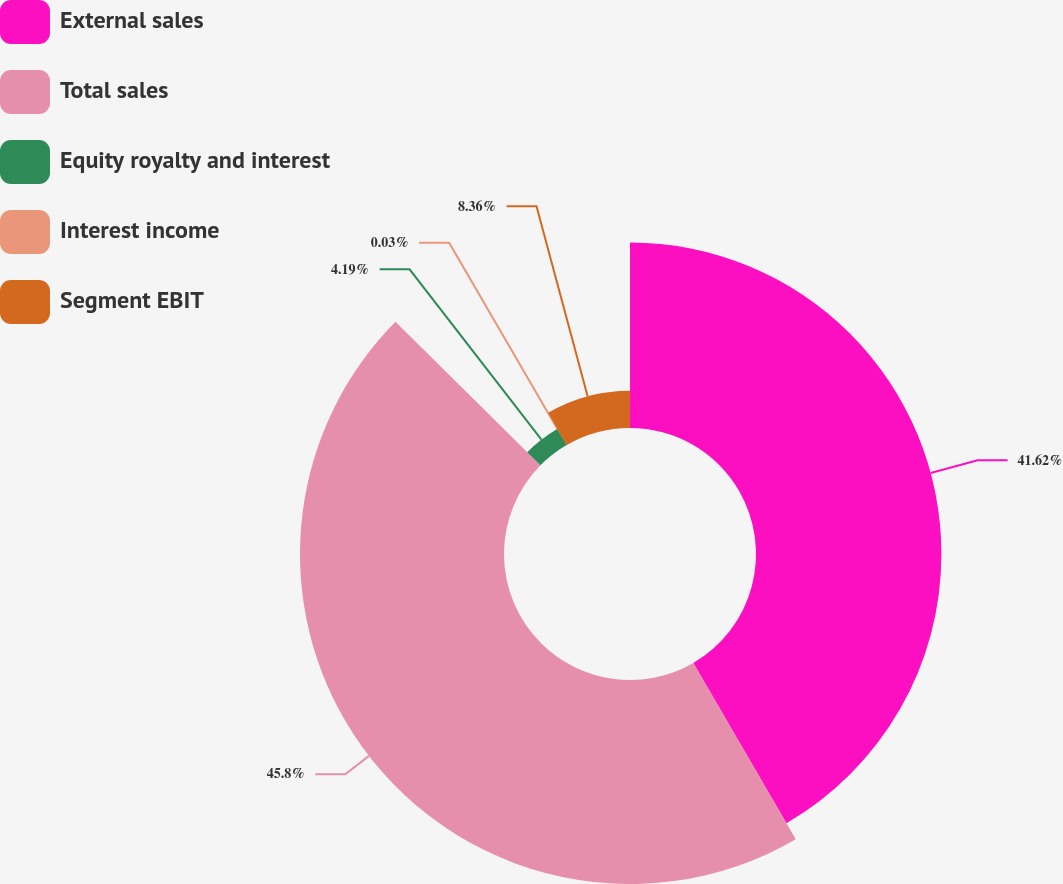Convert chart. <chart><loc_0><loc_0><loc_500><loc_500><pie_chart><fcel>External sales<fcel>Total sales<fcel>Equity royalty and interest<fcel>Interest income<fcel>Segment EBIT<nl><fcel>41.62%<fcel>45.79%<fcel>4.19%<fcel>0.03%<fcel>8.36%<nl></chart> 